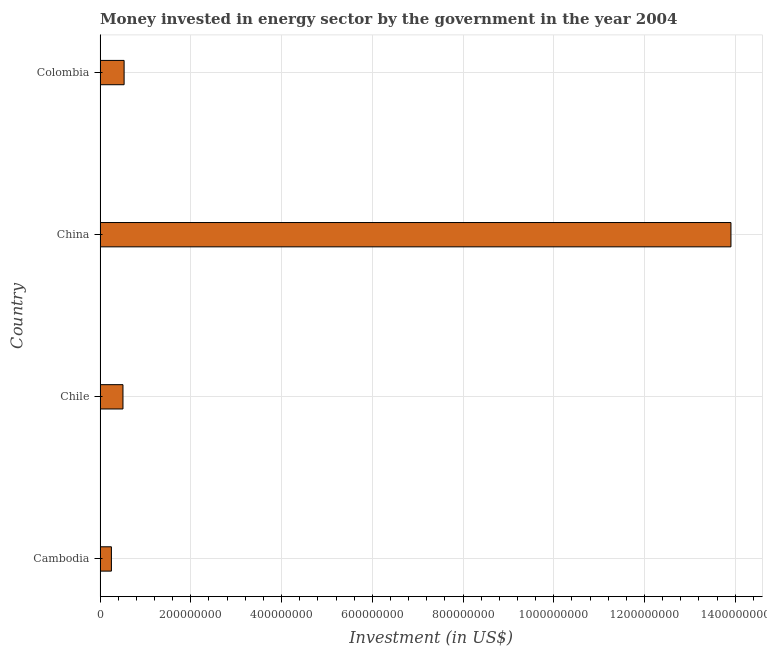Does the graph contain grids?
Offer a terse response. Yes. What is the title of the graph?
Provide a succinct answer. Money invested in energy sector by the government in the year 2004. What is the label or title of the X-axis?
Make the answer very short. Investment (in US$). What is the label or title of the Y-axis?
Give a very brief answer. Country. What is the investment in energy in Cambodia?
Make the answer very short. 2.50e+07. Across all countries, what is the maximum investment in energy?
Offer a very short reply. 1.39e+09. Across all countries, what is the minimum investment in energy?
Keep it short and to the point. 2.50e+07. In which country was the investment in energy minimum?
Provide a succinct answer. Cambodia. What is the sum of the investment in energy?
Provide a short and direct response. 1.52e+09. What is the difference between the investment in energy in Cambodia and Chile?
Provide a short and direct response. -2.55e+07. What is the average investment in energy per country?
Offer a terse response. 3.80e+08. What is the median investment in energy?
Offer a very short reply. 5.18e+07. In how many countries, is the investment in energy greater than 920000000 US$?
Offer a terse response. 1. What is the ratio of the investment in energy in China to that in Colombia?
Your response must be concise. 26.24. Is the investment in energy in Cambodia less than that in Chile?
Give a very brief answer. Yes. What is the difference between the highest and the second highest investment in energy?
Your answer should be compact. 1.34e+09. What is the difference between the highest and the lowest investment in energy?
Give a very brief answer. 1.37e+09. In how many countries, is the investment in energy greater than the average investment in energy taken over all countries?
Your answer should be very brief. 1. How many bars are there?
Offer a terse response. 4. What is the difference between two consecutive major ticks on the X-axis?
Give a very brief answer. 2.00e+08. Are the values on the major ticks of X-axis written in scientific E-notation?
Provide a succinct answer. No. What is the Investment (in US$) of Cambodia?
Provide a short and direct response. 2.50e+07. What is the Investment (in US$) of Chile?
Offer a very short reply. 5.05e+07. What is the Investment (in US$) in China?
Offer a very short reply. 1.39e+09. What is the Investment (in US$) of Colombia?
Keep it short and to the point. 5.30e+07. What is the difference between the Investment (in US$) in Cambodia and Chile?
Your answer should be compact. -2.55e+07. What is the difference between the Investment (in US$) in Cambodia and China?
Keep it short and to the point. -1.37e+09. What is the difference between the Investment (in US$) in Cambodia and Colombia?
Provide a short and direct response. -2.80e+07. What is the difference between the Investment (in US$) in Chile and China?
Make the answer very short. -1.34e+09. What is the difference between the Investment (in US$) in Chile and Colombia?
Your answer should be compact. -2.50e+06. What is the difference between the Investment (in US$) in China and Colombia?
Your answer should be very brief. 1.34e+09. What is the ratio of the Investment (in US$) in Cambodia to that in Chile?
Provide a short and direct response. 0.49. What is the ratio of the Investment (in US$) in Cambodia to that in China?
Your answer should be very brief. 0.02. What is the ratio of the Investment (in US$) in Cambodia to that in Colombia?
Give a very brief answer. 0.47. What is the ratio of the Investment (in US$) in Chile to that in China?
Provide a succinct answer. 0.04. What is the ratio of the Investment (in US$) in Chile to that in Colombia?
Your response must be concise. 0.95. What is the ratio of the Investment (in US$) in China to that in Colombia?
Keep it short and to the point. 26.24. 